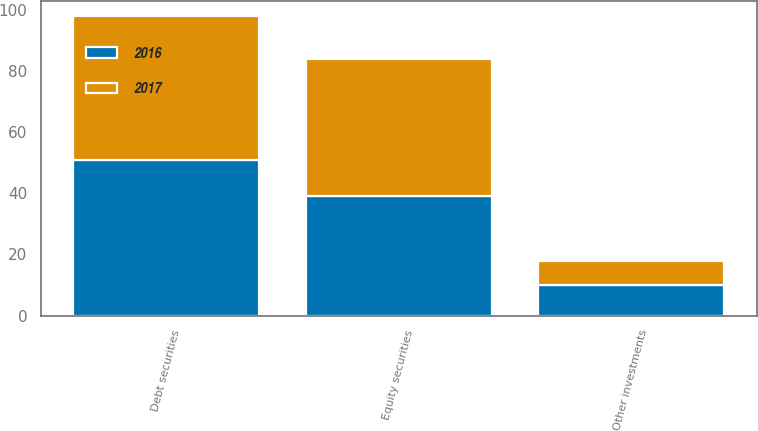Convert chart to OTSL. <chart><loc_0><loc_0><loc_500><loc_500><stacked_bar_chart><ecel><fcel>Equity securities<fcel>Debt securities<fcel>Other investments<nl><fcel>2017<fcel>45<fcel>47<fcel>8<nl><fcel>2016<fcel>39<fcel>51<fcel>10<nl></chart> 